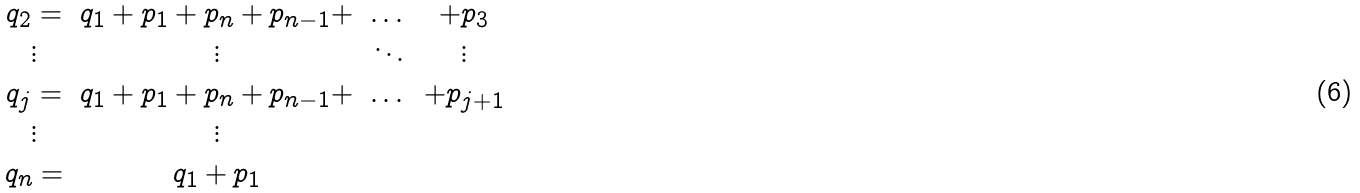<formula> <loc_0><loc_0><loc_500><loc_500>\begin{array} { c c c c } q _ { 2 } = & q _ { 1 } + p _ { 1 } + p _ { n } + p _ { n - 1 } + & \dots & + p _ { 3 } \\ \vdots & \vdots & \ddots & \vdots \\ q _ { j } = & q _ { 1 } + p _ { 1 } + p _ { n } + p _ { n - 1 } + & \dots & + p _ { j + 1 } \\ \vdots & \vdots & & \\ q _ { n } = & q _ { 1 } + p _ { 1 } & & \end{array}</formula> 